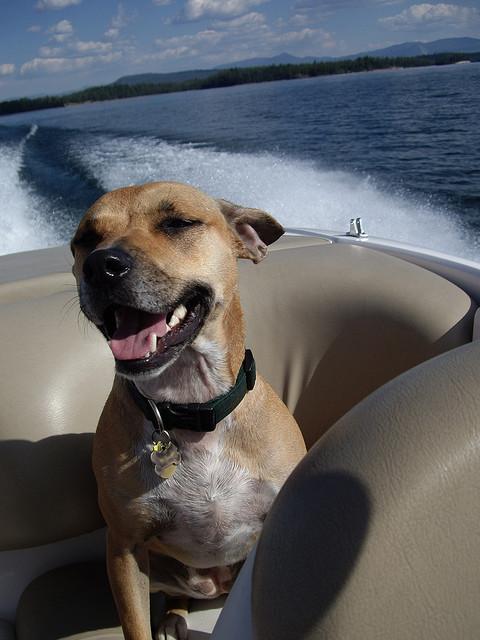Where IS THIS DOG?
Quick response, please. Boat. Are there waves?
Concise answer only. Yes. Is the dog afraid?
Answer briefly. No. 